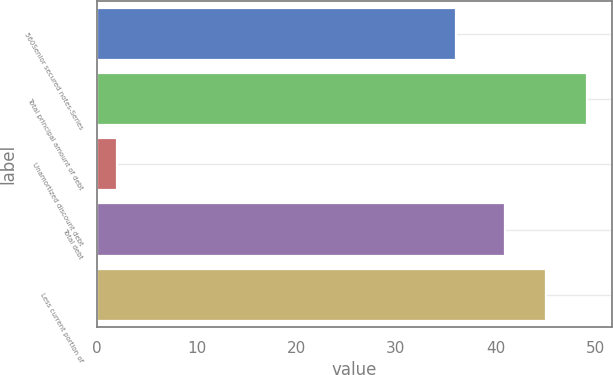Convert chart to OTSL. <chart><loc_0><loc_0><loc_500><loc_500><bar_chart><fcel>560Senior secured notes-Series<fcel>Total principal amount of debt<fcel>Unamortized discount debt<fcel>Total debt<fcel>Less current portion of<nl><fcel>36<fcel>49.2<fcel>2<fcel>41<fcel>45.1<nl></chart> 